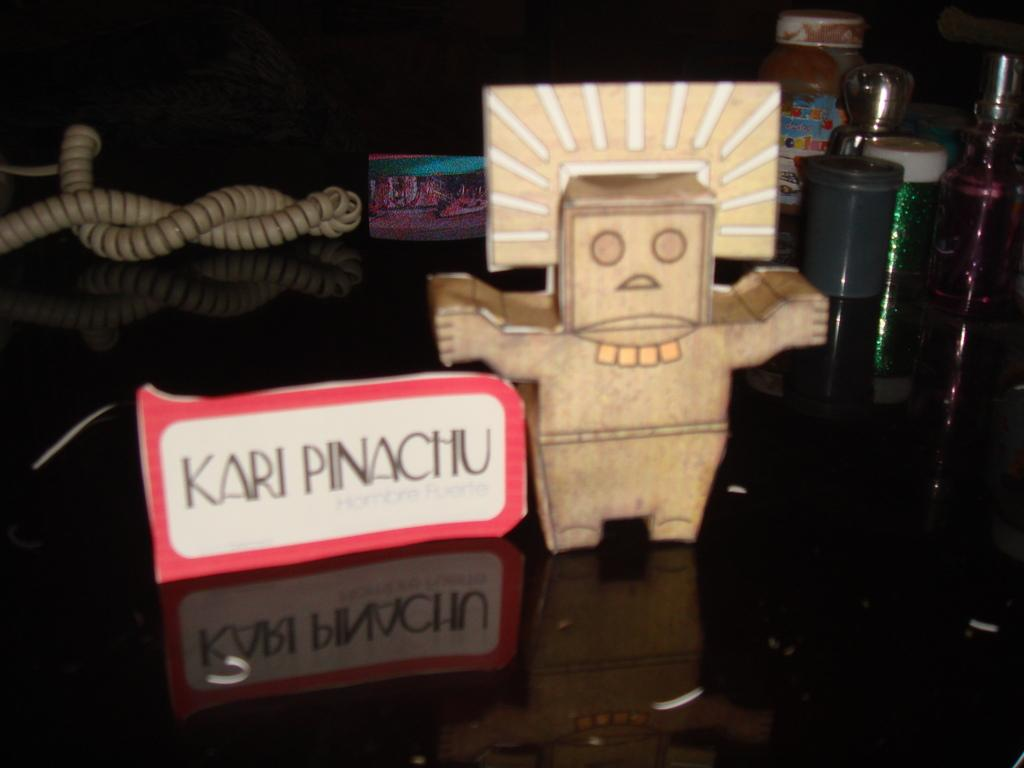What is the main subject of the image? The main subject of the image is an object with "kari pinachu" written beside it. Can you describe any other objects visible in the image? There are other objects in the background of the image. How many dolls are sitting on the toothpaste in the image? There are no dolls or toothpaste present in the image. 